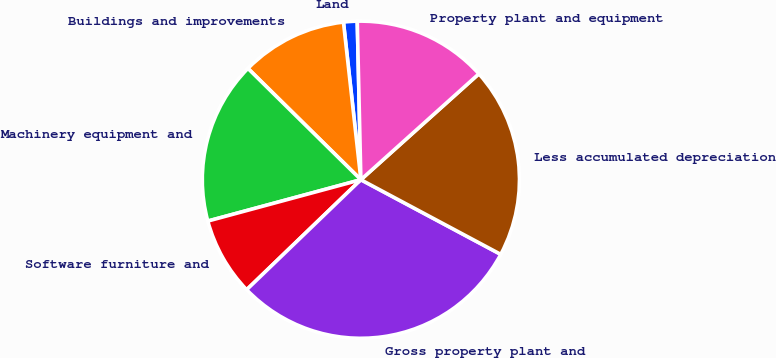Convert chart to OTSL. <chart><loc_0><loc_0><loc_500><loc_500><pie_chart><fcel>Land<fcel>Buildings and improvements<fcel>Machinery equipment and<fcel>Software furniture and<fcel>Gross property plant and<fcel>Less accumulated depreciation<fcel>Property plant and equipment<nl><fcel>1.39%<fcel>10.86%<fcel>16.58%<fcel>8.0%<fcel>29.99%<fcel>19.44%<fcel>13.72%<nl></chart> 